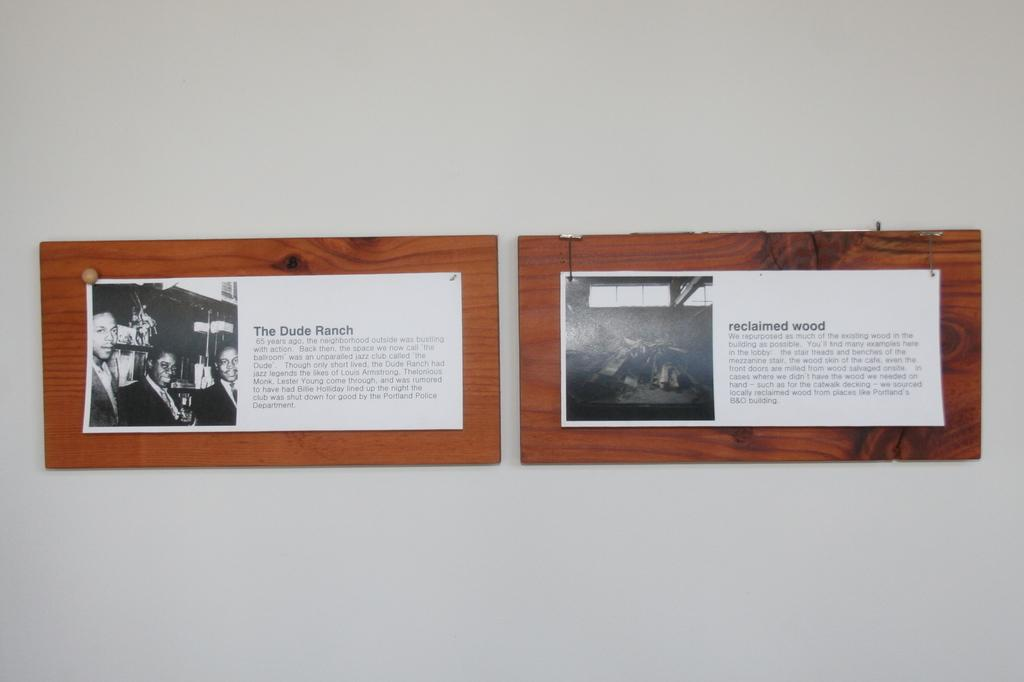What type of objects can be seen in the image? Papers and pins are visible in the image. What material are the wooden objects made of? The wooden objects are made of wood. Where are the wooden objects located in the image? The wooden objects are on a white wall. What type of fruit is being used to hold the papers in the image? There is no fruit present in the image; the wooden objects are holding the papers. How does the love between the pins and papers manifest in the image? There is no indication of love between the pins and papers in the image; they are simply objects in the scene. 